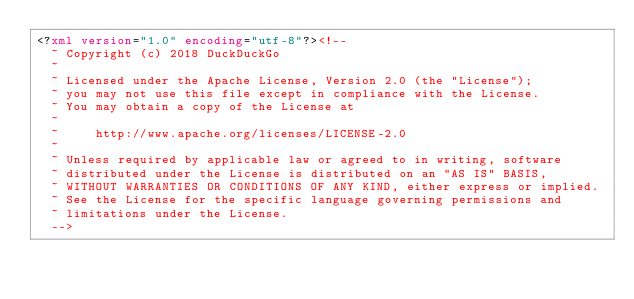<code> <loc_0><loc_0><loc_500><loc_500><_XML_><?xml version="1.0" encoding="utf-8"?><!--
  ~ Copyright (c) 2018 DuckDuckGo
  ~
  ~ Licensed under the Apache License, Version 2.0 (the "License");
  ~ you may not use this file except in compliance with the License.
  ~ You may obtain a copy of the License at
  ~
  ~     http://www.apache.org/licenses/LICENSE-2.0
  ~
  ~ Unless required by applicable law or agreed to in writing, software
  ~ distributed under the License is distributed on an "AS IS" BASIS,
  ~ WITHOUT WARRANTIES OR CONDITIONS OF ANY KIND, either express or implied.
  ~ See the License for the specific language governing permissions and
  ~ limitations under the License.
  -->
</code> 